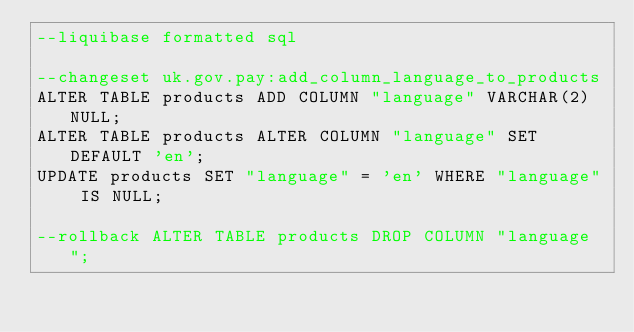<code> <loc_0><loc_0><loc_500><loc_500><_SQL_>--liquibase formatted sql

--changeset uk.gov.pay:add_column_language_to_products
ALTER TABLE products ADD COLUMN "language" VARCHAR(2) NULL;
ALTER TABLE products ALTER COLUMN "language" SET DEFAULT 'en';
UPDATE products SET "language" = 'en' WHERE "language" IS NULL;

--rollback ALTER TABLE products DROP COLUMN "language";
</code> 